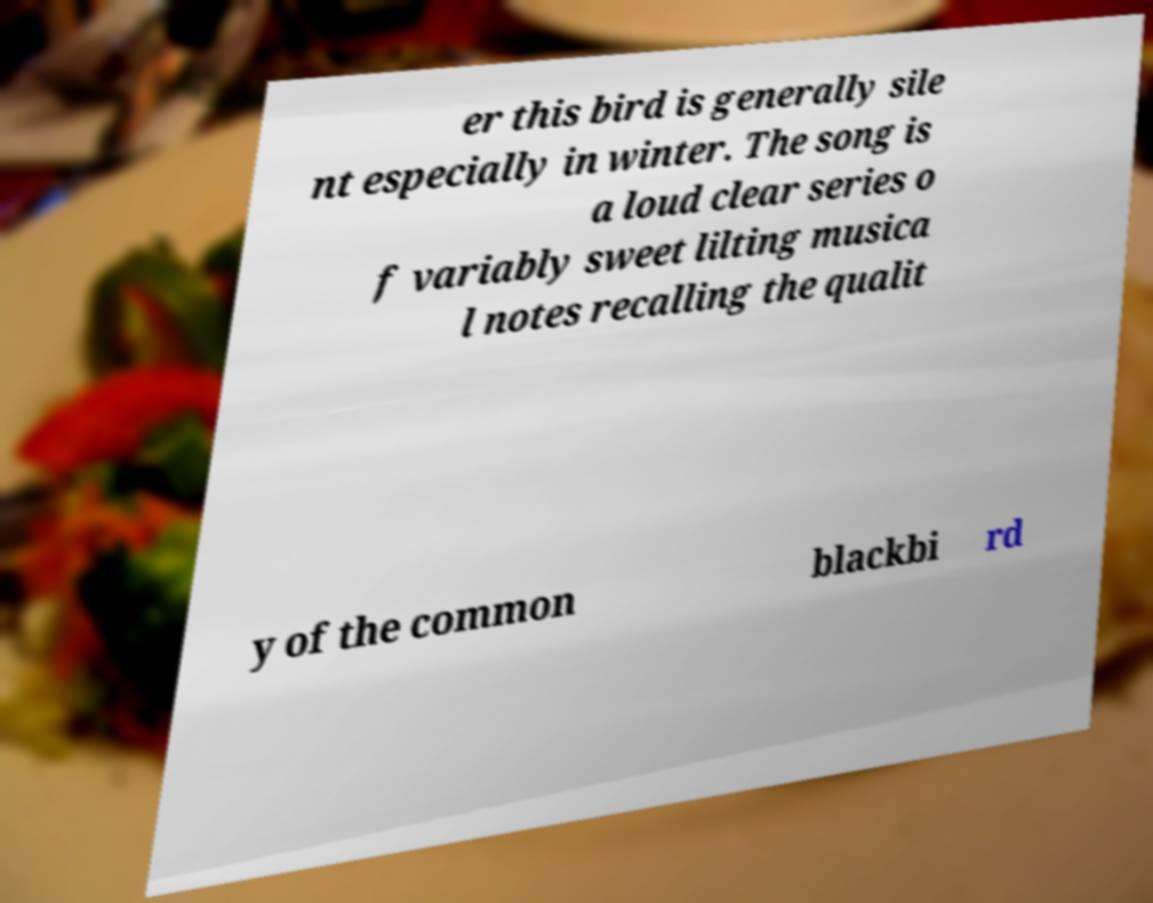Can you read and provide the text displayed in the image?This photo seems to have some interesting text. Can you extract and type it out for me? er this bird is generally sile nt especially in winter. The song is a loud clear series o f variably sweet lilting musica l notes recalling the qualit y of the common blackbi rd 